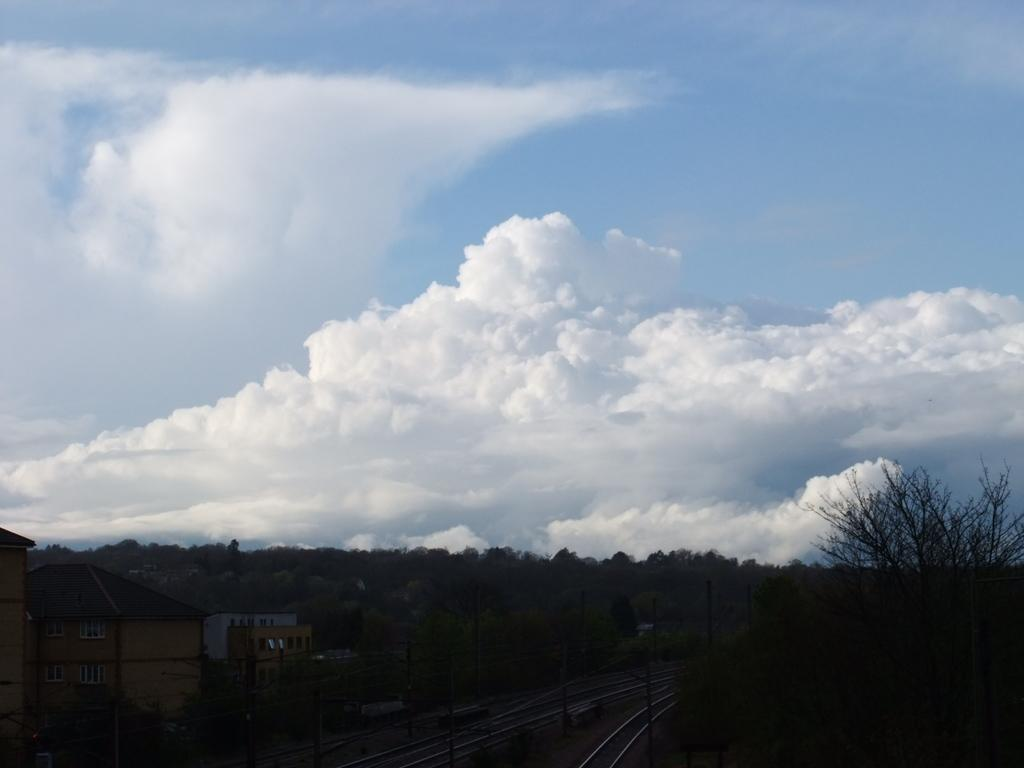What can be seen running through the image? There are train tracks in the image. What structures are located near the train tracks? There are houses beside the train tracks. What type of vegetation is visible in the background of the image? There are trees in the background of the image. What is visible in the sky in the image? The sky is visible in the background of the image. Can you see any donkeys walking along the train tracks in the image? There are no donkeys present in the image. What type of cream is being used to paint the houses beside the train tracks? There is no cream being used to paint the houses in the image; they are not being painted. 